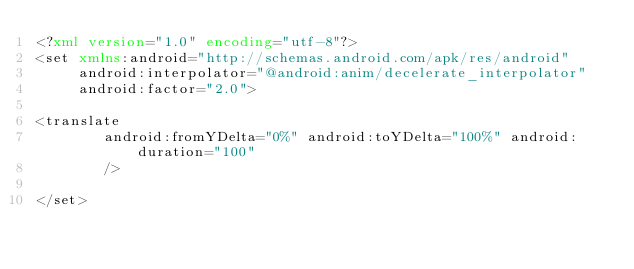<code> <loc_0><loc_0><loc_500><loc_500><_XML_><?xml version="1.0" encoding="utf-8"?>
<set xmlns:android="http://schemas.android.com/apk/res/android"
     android:interpolator="@android:anim/decelerate_interpolator"
     android:factor="2.0">

<translate
        android:fromYDelta="0%" android:toYDelta="100%" android:duration="100"
        />

</set>
</code> 